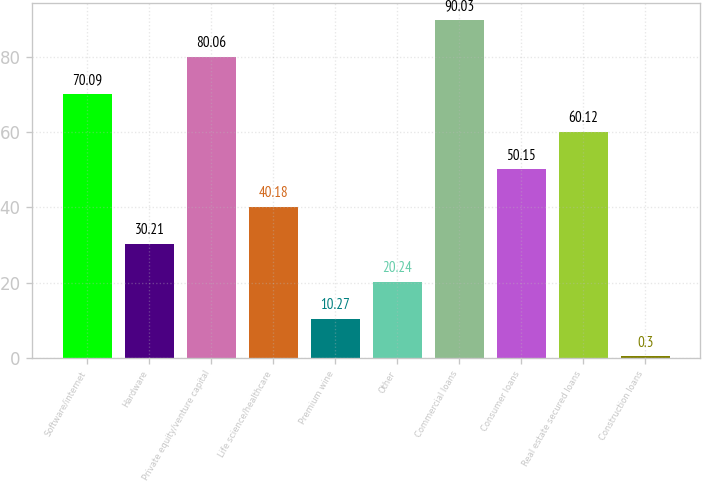Convert chart to OTSL. <chart><loc_0><loc_0><loc_500><loc_500><bar_chart><fcel>Software/internet<fcel>Hardware<fcel>Private equity/venture capital<fcel>Life science/healthcare<fcel>Premium wine<fcel>Other<fcel>Commercial loans<fcel>Consumer loans<fcel>Real estate secured loans<fcel>Construction loans<nl><fcel>70.09<fcel>30.21<fcel>80.06<fcel>40.18<fcel>10.27<fcel>20.24<fcel>90.03<fcel>50.15<fcel>60.12<fcel>0.3<nl></chart> 